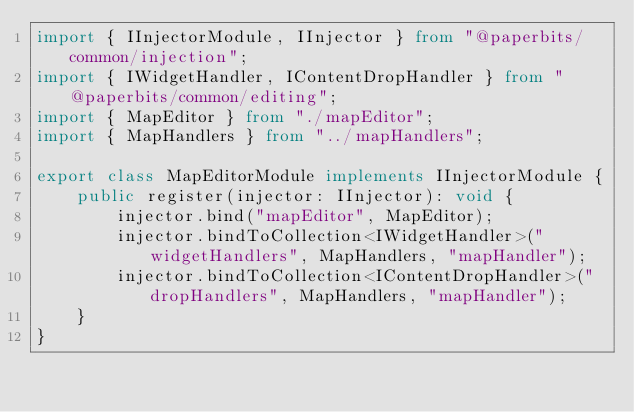Convert code to text. <code><loc_0><loc_0><loc_500><loc_500><_TypeScript_>import { IInjectorModule, IInjector } from "@paperbits/common/injection";
import { IWidgetHandler, IContentDropHandler } from "@paperbits/common/editing";
import { MapEditor } from "./mapEditor";
import { MapHandlers } from "../mapHandlers";

export class MapEditorModule implements IInjectorModule {
    public register(injector: IInjector): void {
        injector.bind("mapEditor", MapEditor);
        injector.bindToCollection<IWidgetHandler>("widgetHandlers", MapHandlers, "mapHandler");
        injector.bindToCollection<IContentDropHandler>("dropHandlers", MapHandlers, "mapHandler");
    }
}</code> 